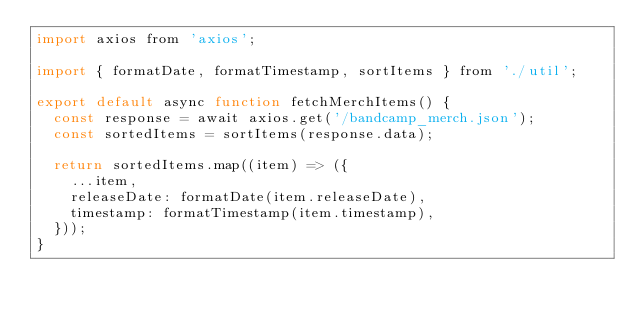Convert code to text. <code><loc_0><loc_0><loc_500><loc_500><_JavaScript_>import axios from 'axios';

import { formatDate, formatTimestamp, sortItems } from './util';

export default async function fetchMerchItems() {
  const response = await axios.get('/bandcamp_merch.json');
  const sortedItems = sortItems(response.data);

  return sortedItems.map((item) => ({
    ...item,
    releaseDate: formatDate(item.releaseDate),
    timestamp: formatTimestamp(item.timestamp),
  }));
}
</code> 